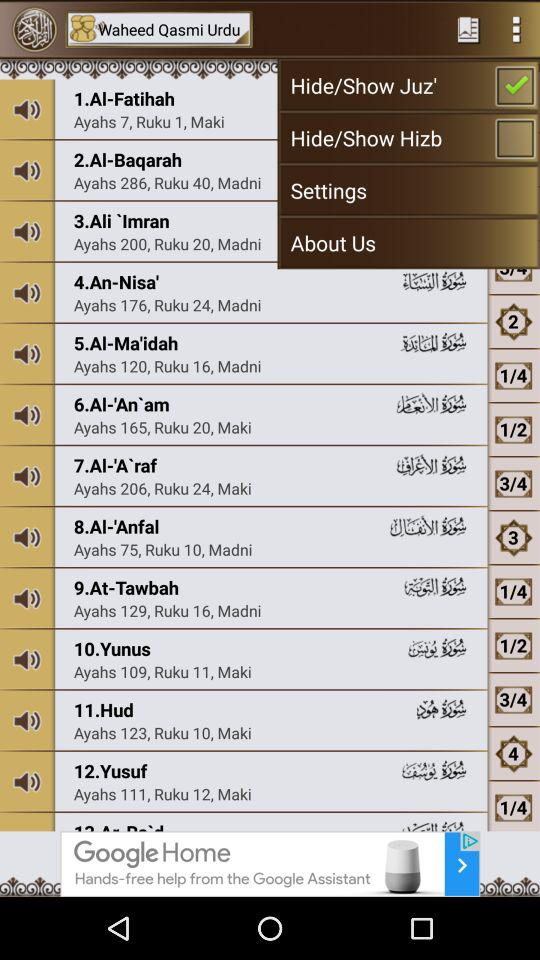How many ayahs are there in "Hud"? There are 123 ayahs in "Hud". 